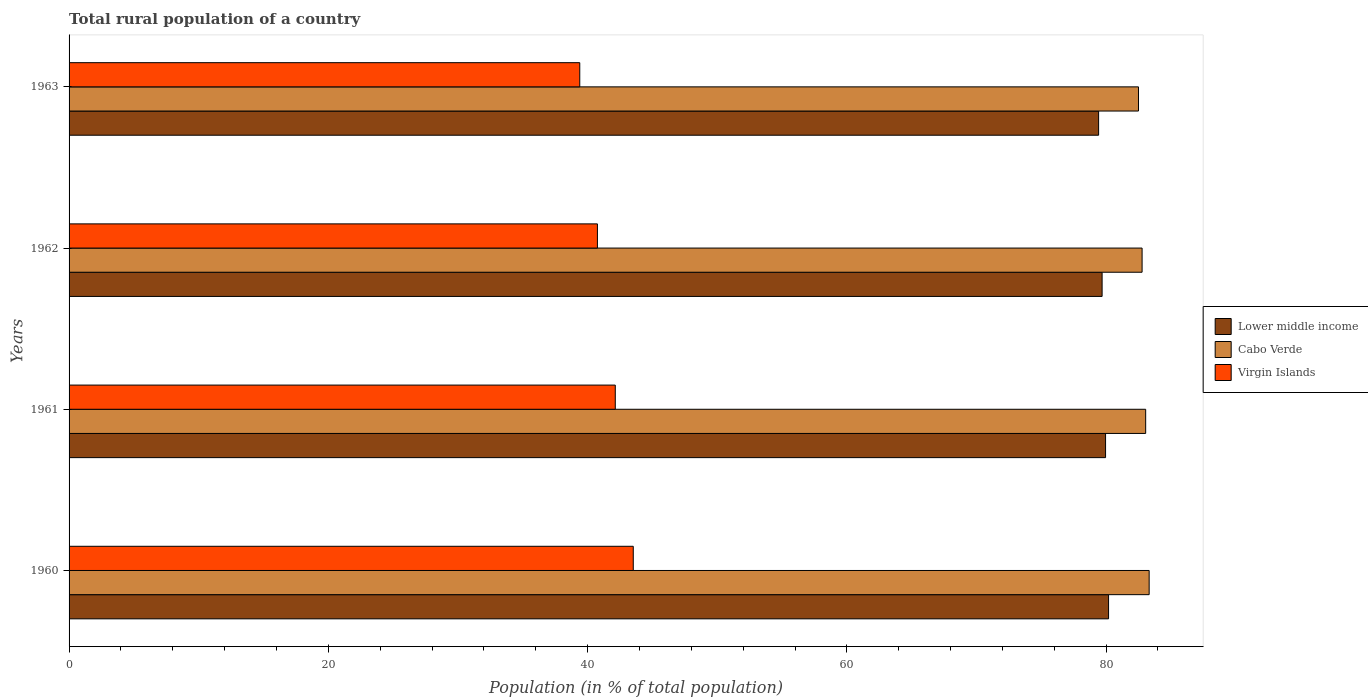How many different coloured bars are there?
Your answer should be compact. 3. How many groups of bars are there?
Make the answer very short. 4. Are the number of bars per tick equal to the number of legend labels?
Make the answer very short. Yes. How many bars are there on the 3rd tick from the top?
Your answer should be compact. 3. How many bars are there on the 3rd tick from the bottom?
Provide a succinct answer. 3. In how many cases, is the number of bars for a given year not equal to the number of legend labels?
Offer a terse response. 0. What is the rural population in Cabo Verde in 1960?
Offer a very short reply. 83.32. Across all years, what is the maximum rural population in Virgin Islands?
Offer a terse response. 43.52. Across all years, what is the minimum rural population in Cabo Verde?
Provide a succinct answer. 82.5. What is the total rural population in Virgin Islands in the graph?
Your response must be concise. 165.81. What is the difference between the rural population in Cabo Verde in 1962 and that in 1963?
Your answer should be compact. 0.28. What is the difference between the rural population in Virgin Islands in 1962 and the rural population in Lower middle income in 1963?
Your answer should be compact. -38.66. What is the average rural population in Cabo Verde per year?
Ensure brevity in your answer.  82.91. In the year 1963, what is the difference between the rural population in Virgin Islands and rural population in Cabo Verde?
Keep it short and to the point. -43.1. What is the ratio of the rural population in Cabo Verde in 1961 to that in 1962?
Provide a succinct answer. 1. What is the difference between the highest and the second highest rural population in Cabo Verde?
Your answer should be very brief. 0.27. What is the difference between the highest and the lowest rural population in Cabo Verde?
Provide a short and direct response. 0.82. In how many years, is the rural population in Virgin Islands greater than the average rural population in Virgin Islands taken over all years?
Give a very brief answer. 2. What does the 3rd bar from the top in 1962 represents?
Ensure brevity in your answer.  Lower middle income. What does the 1st bar from the bottom in 1962 represents?
Provide a short and direct response. Lower middle income. Is it the case that in every year, the sum of the rural population in Lower middle income and rural population in Virgin Islands is greater than the rural population in Cabo Verde?
Ensure brevity in your answer.  Yes. How many years are there in the graph?
Offer a terse response. 4. Does the graph contain any zero values?
Provide a succinct answer. No. Where does the legend appear in the graph?
Offer a very short reply. Center right. How many legend labels are there?
Make the answer very short. 3. What is the title of the graph?
Your answer should be very brief. Total rural population of a country. What is the label or title of the X-axis?
Your answer should be very brief. Population (in % of total population). What is the Population (in % of total population) of Lower middle income in 1960?
Your answer should be very brief. 80.19. What is the Population (in % of total population) in Cabo Verde in 1960?
Provide a short and direct response. 83.32. What is the Population (in % of total population) in Virgin Islands in 1960?
Make the answer very short. 43.52. What is the Population (in % of total population) in Lower middle income in 1961?
Provide a succinct answer. 79.96. What is the Population (in % of total population) in Cabo Verde in 1961?
Offer a very short reply. 83.05. What is the Population (in % of total population) of Virgin Islands in 1961?
Your answer should be very brief. 42.14. What is the Population (in % of total population) of Lower middle income in 1962?
Offer a very short reply. 79.69. What is the Population (in % of total population) of Cabo Verde in 1962?
Ensure brevity in your answer.  82.78. What is the Population (in % of total population) of Virgin Islands in 1962?
Give a very brief answer. 40.76. What is the Population (in % of total population) of Lower middle income in 1963?
Your response must be concise. 79.42. What is the Population (in % of total population) of Cabo Verde in 1963?
Your answer should be very brief. 82.5. What is the Population (in % of total population) in Virgin Islands in 1963?
Make the answer very short. 39.4. Across all years, what is the maximum Population (in % of total population) in Lower middle income?
Give a very brief answer. 80.19. Across all years, what is the maximum Population (in % of total population) of Cabo Verde?
Keep it short and to the point. 83.32. Across all years, what is the maximum Population (in % of total population) of Virgin Islands?
Ensure brevity in your answer.  43.52. Across all years, what is the minimum Population (in % of total population) of Lower middle income?
Give a very brief answer. 79.42. Across all years, what is the minimum Population (in % of total population) of Cabo Verde?
Your answer should be compact. 82.5. Across all years, what is the minimum Population (in % of total population) in Virgin Islands?
Your answer should be very brief. 39.4. What is the total Population (in % of total population) of Lower middle income in the graph?
Give a very brief answer. 319.26. What is the total Population (in % of total population) of Cabo Verde in the graph?
Your answer should be compact. 331.65. What is the total Population (in % of total population) in Virgin Islands in the graph?
Provide a short and direct response. 165.81. What is the difference between the Population (in % of total population) of Lower middle income in 1960 and that in 1961?
Your response must be concise. 0.23. What is the difference between the Population (in % of total population) of Cabo Verde in 1960 and that in 1961?
Offer a terse response. 0.27. What is the difference between the Population (in % of total population) in Virgin Islands in 1960 and that in 1961?
Your answer should be compact. 1.39. What is the difference between the Population (in % of total population) of Lower middle income in 1960 and that in 1962?
Keep it short and to the point. 0.5. What is the difference between the Population (in % of total population) in Cabo Verde in 1960 and that in 1962?
Provide a short and direct response. 0.55. What is the difference between the Population (in % of total population) in Virgin Islands in 1960 and that in 1962?
Provide a succinct answer. 2.76. What is the difference between the Population (in % of total population) of Lower middle income in 1960 and that in 1963?
Ensure brevity in your answer.  0.77. What is the difference between the Population (in % of total population) of Cabo Verde in 1960 and that in 1963?
Keep it short and to the point. 0.82. What is the difference between the Population (in % of total population) of Virgin Islands in 1960 and that in 1963?
Your answer should be very brief. 4.13. What is the difference between the Population (in % of total population) of Lower middle income in 1961 and that in 1962?
Keep it short and to the point. 0.27. What is the difference between the Population (in % of total population) of Cabo Verde in 1961 and that in 1962?
Keep it short and to the point. 0.28. What is the difference between the Population (in % of total population) in Virgin Islands in 1961 and that in 1962?
Ensure brevity in your answer.  1.38. What is the difference between the Population (in % of total population) of Lower middle income in 1961 and that in 1963?
Provide a succinct answer. 0.54. What is the difference between the Population (in % of total population) of Cabo Verde in 1961 and that in 1963?
Provide a short and direct response. 0.56. What is the difference between the Population (in % of total population) of Virgin Islands in 1961 and that in 1963?
Provide a succinct answer. 2.74. What is the difference between the Population (in % of total population) of Lower middle income in 1962 and that in 1963?
Offer a very short reply. 0.27. What is the difference between the Population (in % of total population) in Cabo Verde in 1962 and that in 1963?
Keep it short and to the point. 0.28. What is the difference between the Population (in % of total population) of Virgin Islands in 1962 and that in 1963?
Your answer should be compact. 1.36. What is the difference between the Population (in % of total population) in Lower middle income in 1960 and the Population (in % of total population) in Cabo Verde in 1961?
Provide a succinct answer. -2.86. What is the difference between the Population (in % of total population) of Lower middle income in 1960 and the Population (in % of total population) of Virgin Islands in 1961?
Your response must be concise. 38.05. What is the difference between the Population (in % of total population) in Cabo Verde in 1960 and the Population (in % of total population) in Virgin Islands in 1961?
Provide a short and direct response. 41.19. What is the difference between the Population (in % of total population) in Lower middle income in 1960 and the Population (in % of total population) in Cabo Verde in 1962?
Offer a very short reply. -2.59. What is the difference between the Population (in % of total population) of Lower middle income in 1960 and the Population (in % of total population) of Virgin Islands in 1962?
Ensure brevity in your answer.  39.43. What is the difference between the Population (in % of total population) in Cabo Verde in 1960 and the Population (in % of total population) in Virgin Islands in 1962?
Provide a succinct answer. 42.56. What is the difference between the Population (in % of total population) of Lower middle income in 1960 and the Population (in % of total population) of Cabo Verde in 1963?
Make the answer very short. -2.31. What is the difference between the Population (in % of total population) in Lower middle income in 1960 and the Population (in % of total population) in Virgin Islands in 1963?
Make the answer very short. 40.79. What is the difference between the Population (in % of total population) of Cabo Verde in 1960 and the Population (in % of total population) of Virgin Islands in 1963?
Make the answer very short. 43.92. What is the difference between the Population (in % of total population) of Lower middle income in 1961 and the Population (in % of total population) of Cabo Verde in 1962?
Ensure brevity in your answer.  -2.82. What is the difference between the Population (in % of total population) in Lower middle income in 1961 and the Population (in % of total population) in Virgin Islands in 1962?
Your answer should be compact. 39.2. What is the difference between the Population (in % of total population) of Cabo Verde in 1961 and the Population (in % of total population) of Virgin Islands in 1962?
Make the answer very short. 42.29. What is the difference between the Population (in % of total population) of Lower middle income in 1961 and the Population (in % of total population) of Cabo Verde in 1963?
Offer a very short reply. -2.54. What is the difference between the Population (in % of total population) of Lower middle income in 1961 and the Population (in % of total population) of Virgin Islands in 1963?
Offer a very short reply. 40.56. What is the difference between the Population (in % of total population) in Cabo Verde in 1961 and the Population (in % of total population) in Virgin Islands in 1963?
Make the answer very short. 43.66. What is the difference between the Population (in % of total population) in Lower middle income in 1962 and the Population (in % of total population) in Cabo Verde in 1963?
Your answer should be very brief. -2.81. What is the difference between the Population (in % of total population) of Lower middle income in 1962 and the Population (in % of total population) of Virgin Islands in 1963?
Provide a succinct answer. 40.3. What is the difference between the Population (in % of total population) of Cabo Verde in 1962 and the Population (in % of total population) of Virgin Islands in 1963?
Provide a short and direct response. 43.38. What is the average Population (in % of total population) of Lower middle income per year?
Keep it short and to the point. 79.81. What is the average Population (in % of total population) of Cabo Verde per year?
Make the answer very short. 82.91. What is the average Population (in % of total population) of Virgin Islands per year?
Provide a succinct answer. 41.45. In the year 1960, what is the difference between the Population (in % of total population) in Lower middle income and Population (in % of total population) in Cabo Verde?
Give a very brief answer. -3.13. In the year 1960, what is the difference between the Population (in % of total population) of Lower middle income and Population (in % of total population) of Virgin Islands?
Your answer should be compact. 36.67. In the year 1960, what is the difference between the Population (in % of total population) in Cabo Verde and Population (in % of total population) in Virgin Islands?
Your answer should be very brief. 39.8. In the year 1961, what is the difference between the Population (in % of total population) of Lower middle income and Population (in % of total population) of Cabo Verde?
Your answer should be compact. -3.09. In the year 1961, what is the difference between the Population (in % of total population) in Lower middle income and Population (in % of total population) in Virgin Islands?
Offer a terse response. 37.82. In the year 1961, what is the difference between the Population (in % of total population) of Cabo Verde and Population (in % of total population) of Virgin Islands?
Give a very brief answer. 40.92. In the year 1962, what is the difference between the Population (in % of total population) in Lower middle income and Population (in % of total population) in Cabo Verde?
Provide a succinct answer. -3.08. In the year 1962, what is the difference between the Population (in % of total population) in Lower middle income and Population (in % of total population) in Virgin Islands?
Provide a short and direct response. 38.93. In the year 1962, what is the difference between the Population (in % of total population) of Cabo Verde and Population (in % of total population) of Virgin Islands?
Your answer should be very brief. 42.02. In the year 1963, what is the difference between the Population (in % of total population) in Lower middle income and Population (in % of total population) in Cabo Verde?
Ensure brevity in your answer.  -3.08. In the year 1963, what is the difference between the Population (in % of total population) of Lower middle income and Population (in % of total population) of Virgin Islands?
Provide a succinct answer. 40.03. In the year 1963, what is the difference between the Population (in % of total population) of Cabo Verde and Population (in % of total population) of Virgin Islands?
Make the answer very short. 43.1. What is the ratio of the Population (in % of total population) in Lower middle income in 1960 to that in 1961?
Your answer should be very brief. 1. What is the ratio of the Population (in % of total population) of Cabo Verde in 1960 to that in 1961?
Keep it short and to the point. 1. What is the ratio of the Population (in % of total population) in Virgin Islands in 1960 to that in 1961?
Give a very brief answer. 1.03. What is the ratio of the Population (in % of total population) of Lower middle income in 1960 to that in 1962?
Make the answer very short. 1.01. What is the ratio of the Population (in % of total population) in Cabo Verde in 1960 to that in 1962?
Your answer should be very brief. 1.01. What is the ratio of the Population (in % of total population) of Virgin Islands in 1960 to that in 1962?
Keep it short and to the point. 1.07. What is the ratio of the Population (in % of total population) of Lower middle income in 1960 to that in 1963?
Your response must be concise. 1.01. What is the ratio of the Population (in % of total population) in Cabo Verde in 1960 to that in 1963?
Your answer should be compact. 1.01. What is the ratio of the Population (in % of total population) of Virgin Islands in 1960 to that in 1963?
Offer a terse response. 1.1. What is the ratio of the Population (in % of total population) of Virgin Islands in 1961 to that in 1962?
Provide a short and direct response. 1.03. What is the ratio of the Population (in % of total population) of Virgin Islands in 1961 to that in 1963?
Your answer should be very brief. 1.07. What is the ratio of the Population (in % of total population) of Lower middle income in 1962 to that in 1963?
Provide a short and direct response. 1. What is the ratio of the Population (in % of total population) in Cabo Verde in 1962 to that in 1963?
Offer a terse response. 1. What is the ratio of the Population (in % of total population) of Virgin Islands in 1962 to that in 1963?
Provide a short and direct response. 1.03. What is the difference between the highest and the second highest Population (in % of total population) in Lower middle income?
Your response must be concise. 0.23. What is the difference between the highest and the second highest Population (in % of total population) in Cabo Verde?
Provide a succinct answer. 0.27. What is the difference between the highest and the second highest Population (in % of total population) in Virgin Islands?
Ensure brevity in your answer.  1.39. What is the difference between the highest and the lowest Population (in % of total population) in Lower middle income?
Keep it short and to the point. 0.77. What is the difference between the highest and the lowest Population (in % of total population) of Cabo Verde?
Your answer should be compact. 0.82. What is the difference between the highest and the lowest Population (in % of total population) of Virgin Islands?
Offer a very short reply. 4.13. 